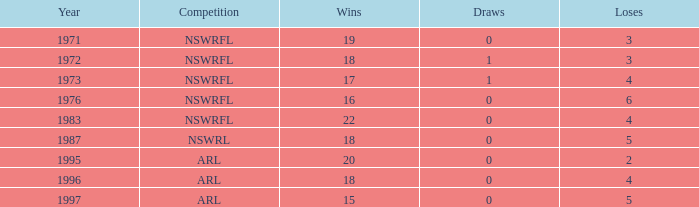What sum of Losses has Year greater than 1972, and Competition of nswrfl, and Draws 0, and Wins 16? 6.0. 